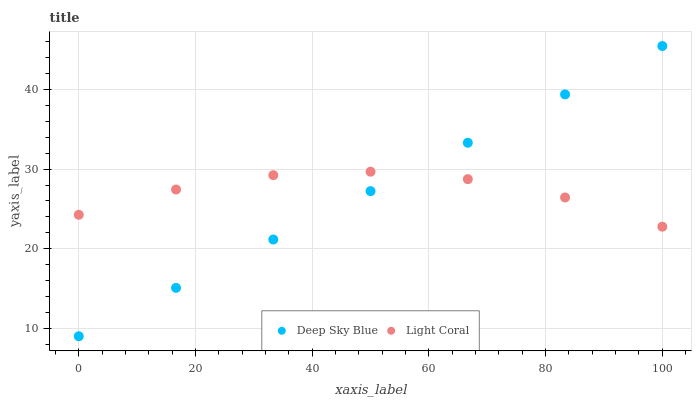Does Deep Sky Blue have the minimum area under the curve?
Answer yes or no. Yes. Does Light Coral have the maximum area under the curve?
Answer yes or no. Yes. Does Deep Sky Blue have the maximum area under the curve?
Answer yes or no. No. Is Deep Sky Blue the smoothest?
Answer yes or no. Yes. Is Light Coral the roughest?
Answer yes or no. Yes. Is Deep Sky Blue the roughest?
Answer yes or no. No. Does Deep Sky Blue have the lowest value?
Answer yes or no. Yes. Does Deep Sky Blue have the highest value?
Answer yes or no. Yes. Does Deep Sky Blue intersect Light Coral?
Answer yes or no. Yes. Is Deep Sky Blue less than Light Coral?
Answer yes or no. No. Is Deep Sky Blue greater than Light Coral?
Answer yes or no. No. 